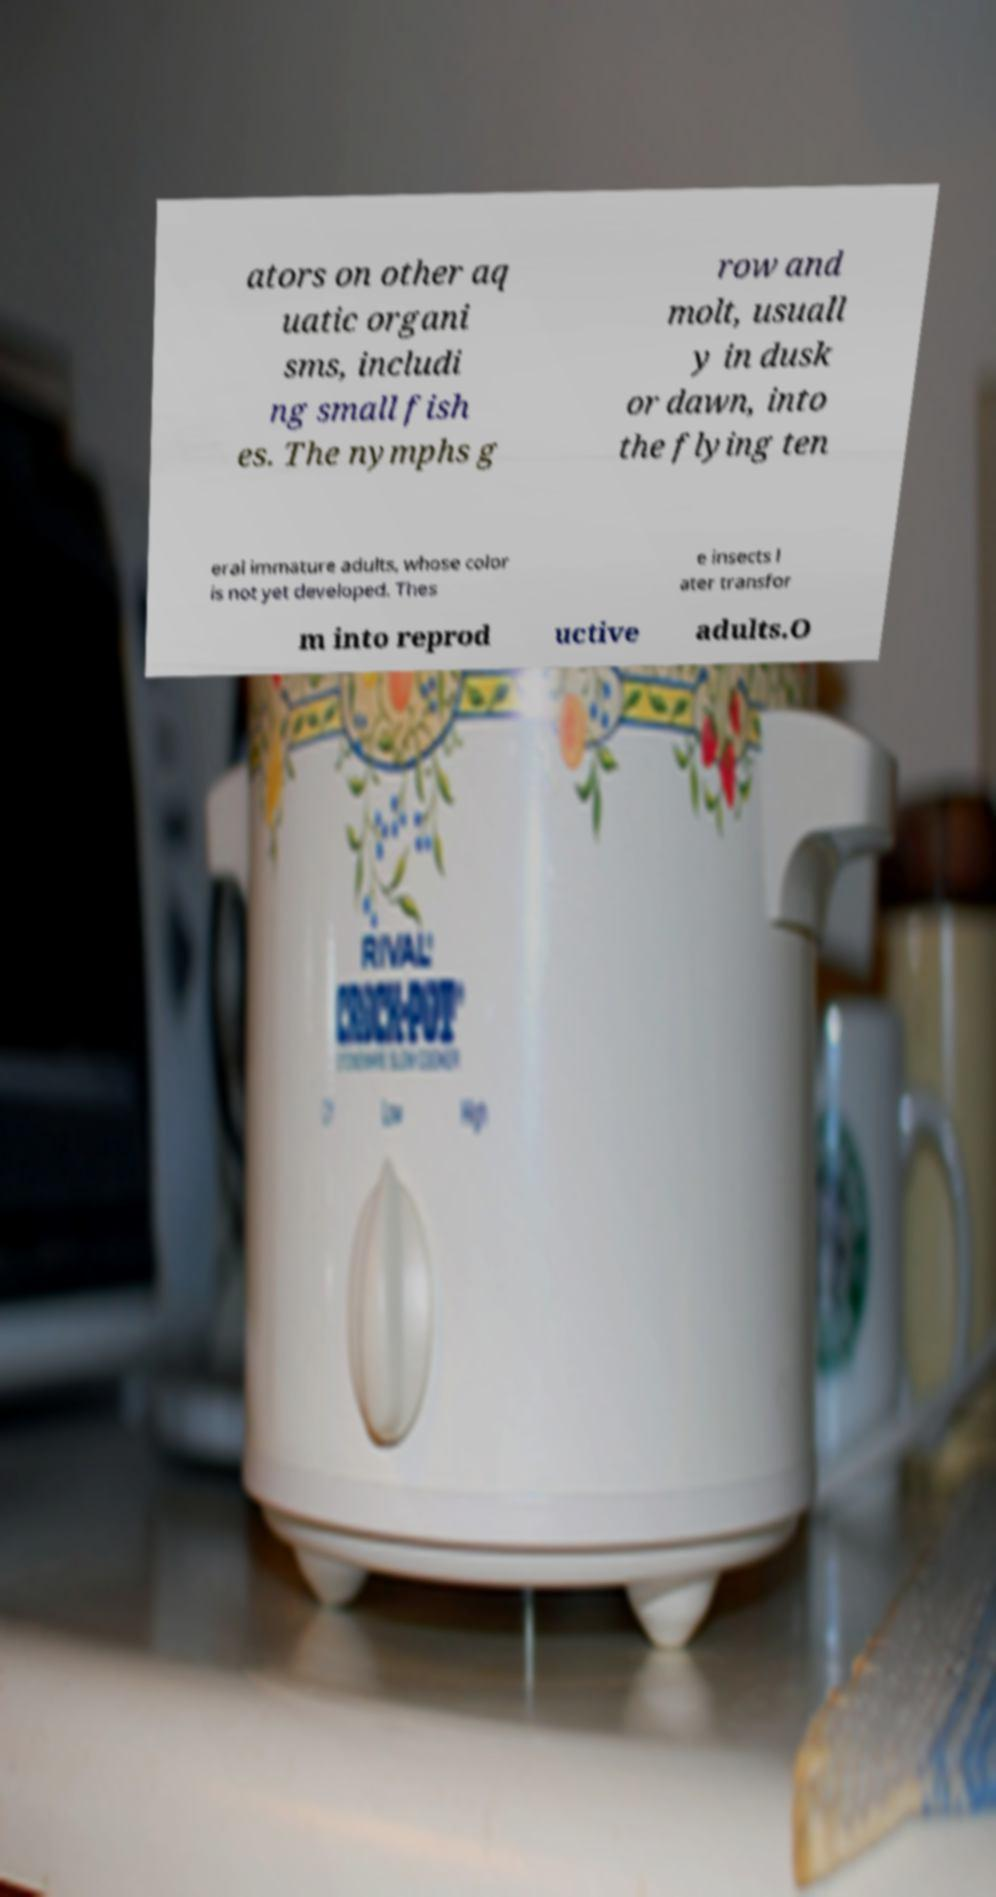Could you extract and type out the text from this image? ators on other aq uatic organi sms, includi ng small fish es. The nymphs g row and molt, usuall y in dusk or dawn, into the flying ten eral immature adults, whose color is not yet developed. Thes e insects l ater transfor m into reprod uctive adults.O 